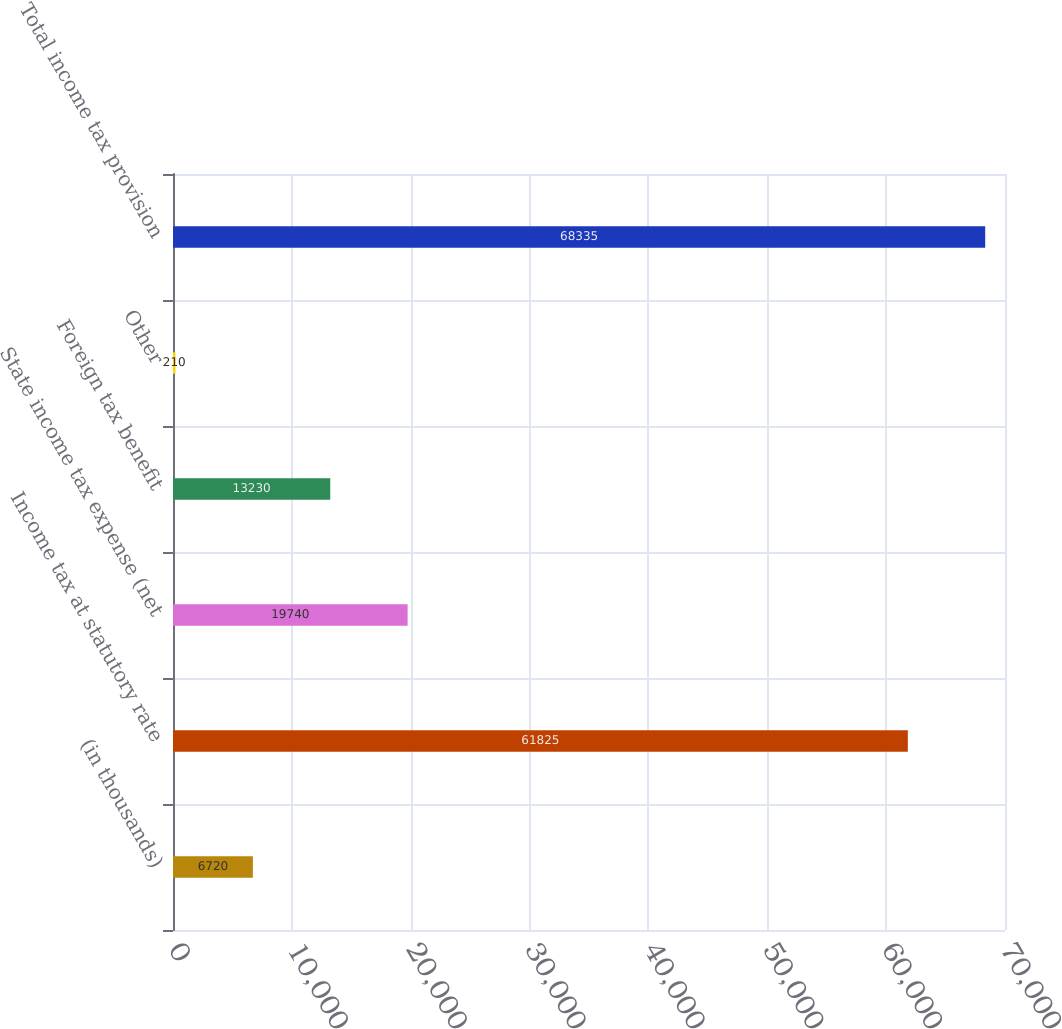<chart> <loc_0><loc_0><loc_500><loc_500><bar_chart><fcel>(in thousands)<fcel>Income tax at statutory rate<fcel>State income tax expense (net<fcel>Foreign tax benefit<fcel>Other<fcel>Total income tax provision<nl><fcel>6720<fcel>61825<fcel>19740<fcel>13230<fcel>210<fcel>68335<nl></chart> 